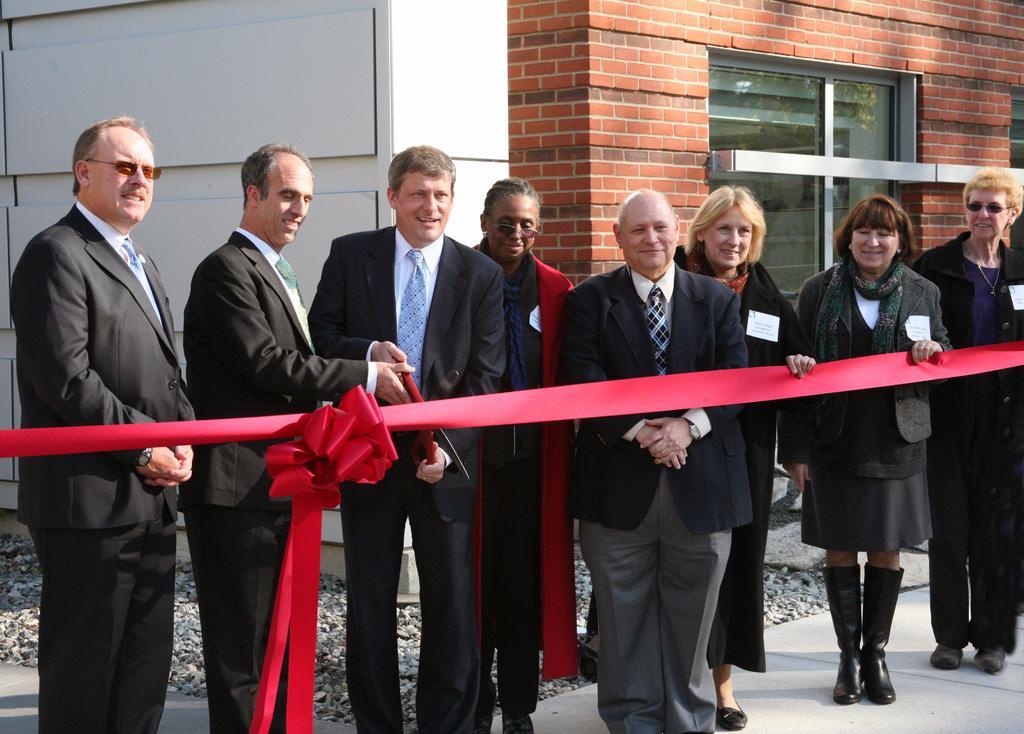Could you give a brief overview of what you see in this image? In this picture there are group of people standing and there is a person standing and holding the scissors. At the back there is a building and there is reflection of tree on the mirror. At the bottom there is a road and there are stones. 